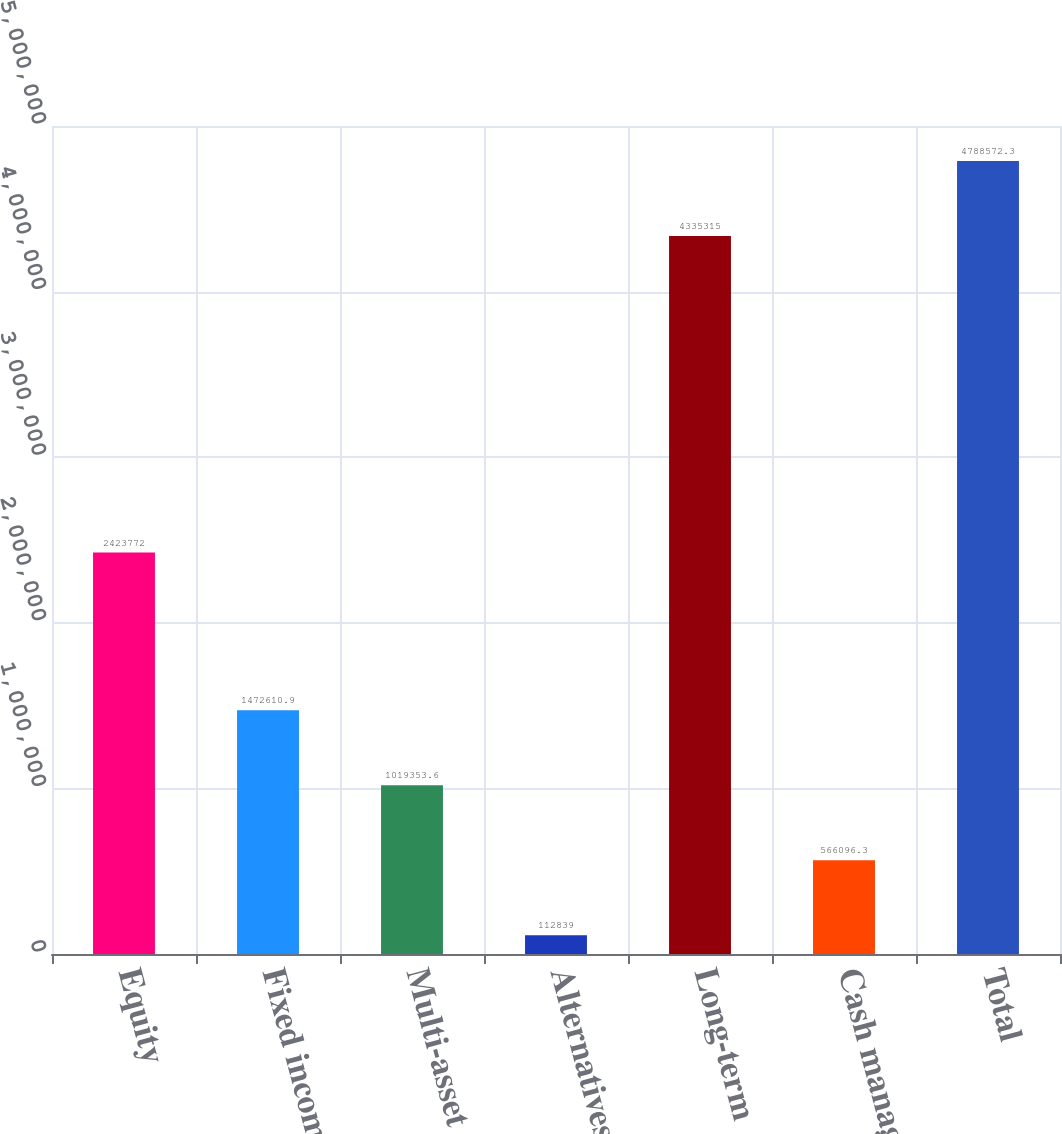Convert chart to OTSL. <chart><loc_0><loc_0><loc_500><loc_500><bar_chart><fcel>Equity<fcel>Fixed income<fcel>Multi-asset class<fcel>Alternatives<fcel>Long-term<fcel>Cash management<fcel>Total<nl><fcel>2.42377e+06<fcel>1.47261e+06<fcel>1.01935e+06<fcel>112839<fcel>4.33532e+06<fcel>566096<fcel>4.78857e+06<nl></chart> 